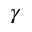Convert formula to latex. <formula><loc_0><loc_0><loc_500><loc_500>\gamma</formula> 